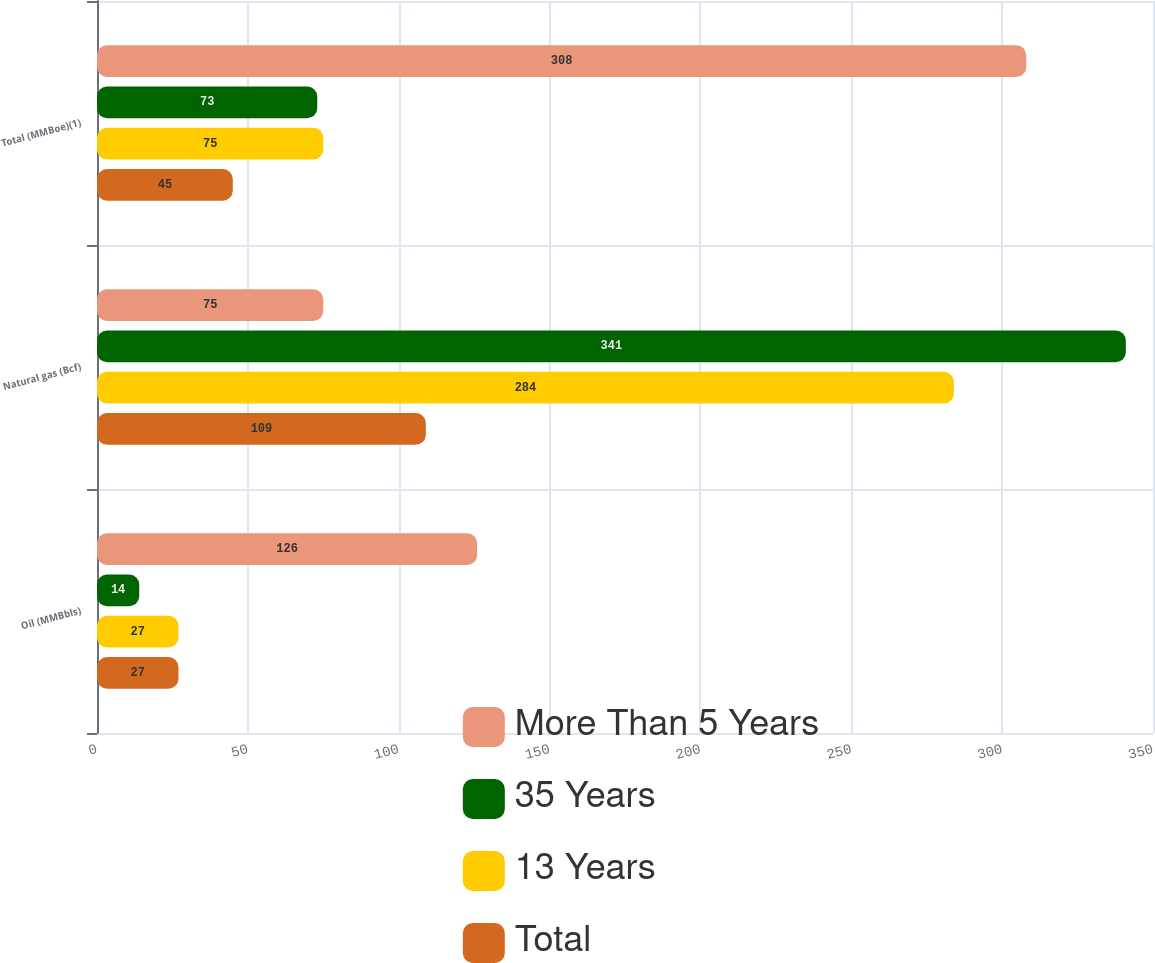Convert chart. <chart><loc_0><loc_0><loc_500><loc_500><stacked_bar_chart><ecel><fcel>Oil (MMBbls)<fcel>Natural gas (Bcf)<fcel>Total (MMBoe)(1)<nl><fcel>More Than 5 Years<fcel>126<fcel>75<fcel>308<nl><fcel>35 Years<fcel>14<fcel>341<fcel>73<nl><fcel>13 Years<fcel>27<fcel>284<fcel>75<nl><fcel>Total<fcel>27<fcel>109<fcel>45<nl></chart> 